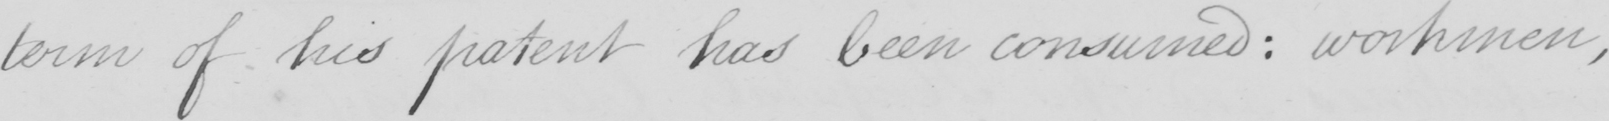Can you tell me what this handwritten text says? term of his patent has been consumed :  workmen , 